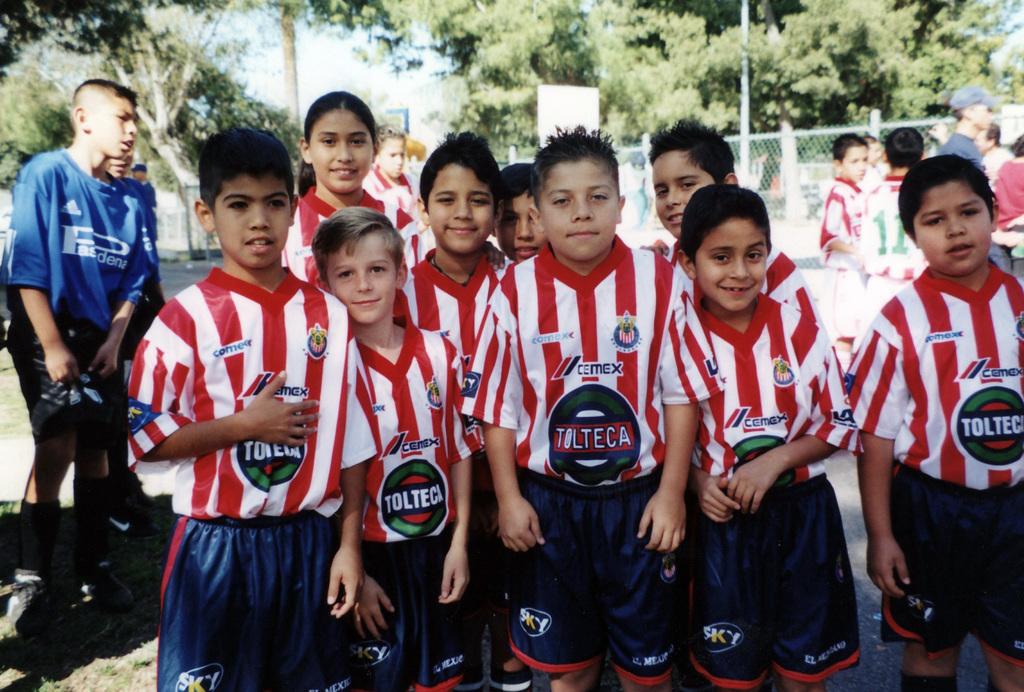What's the team name on the front of the childrens' jerseys?
Offer a very short reply. Tolteca. What is the word on the children's shorts?
Provide a succinct answer. Sky. 